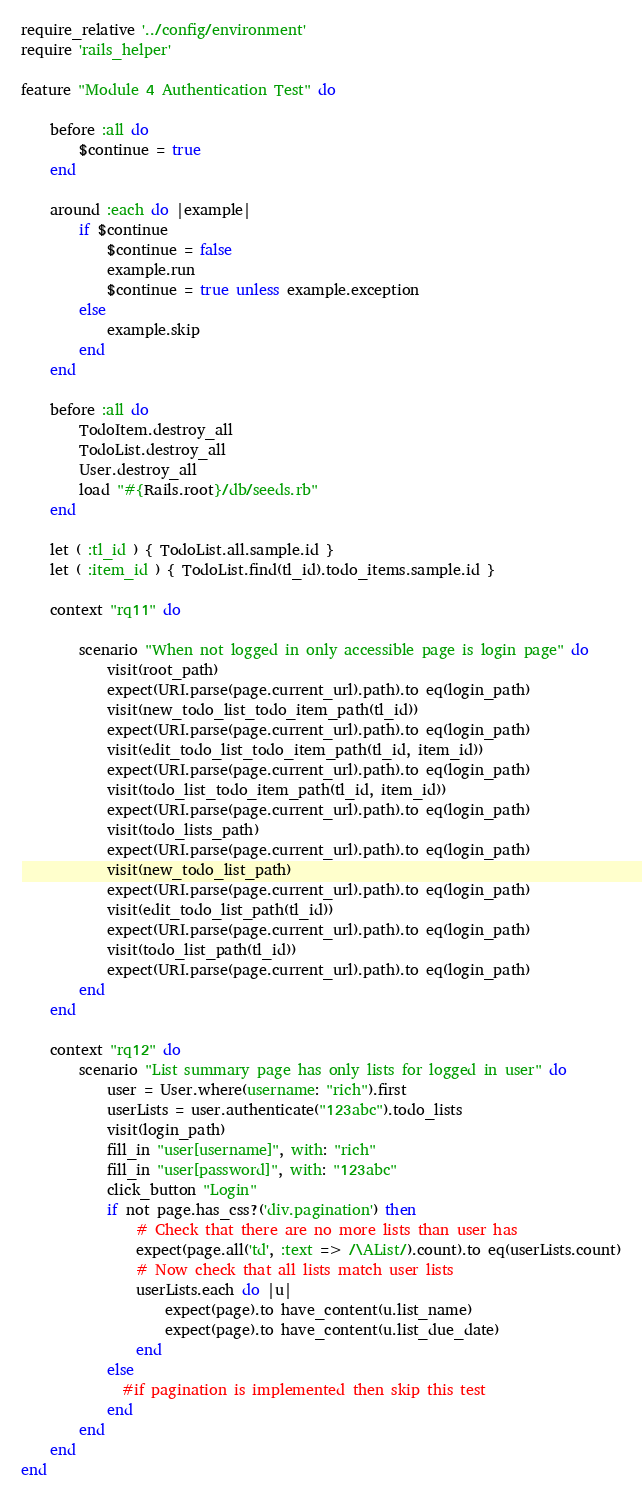<code> <loc_0><loc_0><loc_500><loc_500><_Ruby_>require_relative '../config/environment'
require 'rails_helper'

feature "Module 4 Authentication Test" do

    before :all do
        $continue = true
    end

    around :each do |example|
        if $continue
            $continue = false 
            example.run 
            $continue = true unless example.exception
        else
            example.skip
        end
    end

    before :all do 
        TodoItem.destroy_all
        TodoList.destroy_all
        User.destroy_all
        load "#{Rails.root}/db/seeds.rb"  
    end

    let ( :tl_id ) { TodoList.all.sample.id }
    let ( :item_id ) { TodoList.find(tl_id).todo_items.sample.id }

    context "rq11" do

        scenario "When not logged in only accessible page is login page" do
            visit(root_path)
            expect(URI.parse(page.current_url).path).to eq(login_path)
            visit(new_todo_list_todo_item_path(tl_id))
            expect(URI.parse(page.current_url).path).to eq(login_path)            
            visit(edit_todo_list_todo_item_path(tl_id, item_id))
            expect(URI.parse(page.current_url).path).to eq(login_path)
            visit(todo_list_todo_item_path(tl_id, item_id))
            expect(URI.parse(page.current_url).path).to eq(login_path)   
            visit(todo_lists_path)
            expect(URI.parse(page.current_url).path).to eq(login_path)     
            visit(new_todo_list_path)
            expect(URI.parse(page.current_url).path).to eq(login_path)     
            visit(edit_todo_list_path(tl_id))
            expect(URI.parse(page.current_url).path).to eq(login_path)   
            visit(todo_list_path(tl_id))
            expect(URI.parse(page.current_url).path).to eq(login_path)  
        end
    end

    context "rq12" do
        scenario "List summary page has only lists for logged in user" do
            user = User.where(username: "rich").first
            userLists = user.authenticate("123abc").todo_lists
            visit(login_path)
            fill_in "user[username]", with: "rich"
            fill_in "user[password]", with: "123abc"
            click_button "Login"
            if not page.has_css?('div.pagination') then
                # Check that there are no more lists than user has
                expect(page.all('td', :text => /\AList/).count).to eq(userLists.count)
                # Now check that all lists match user lists
                userLists.each do |u|
                    expect(page).to have_content(u.list_name)
                    expect(page).to have_content(u.list_due_date)
                end
            else
              #if pagination is implemented then skip this test
            end    
        end
    end
end
</code> 